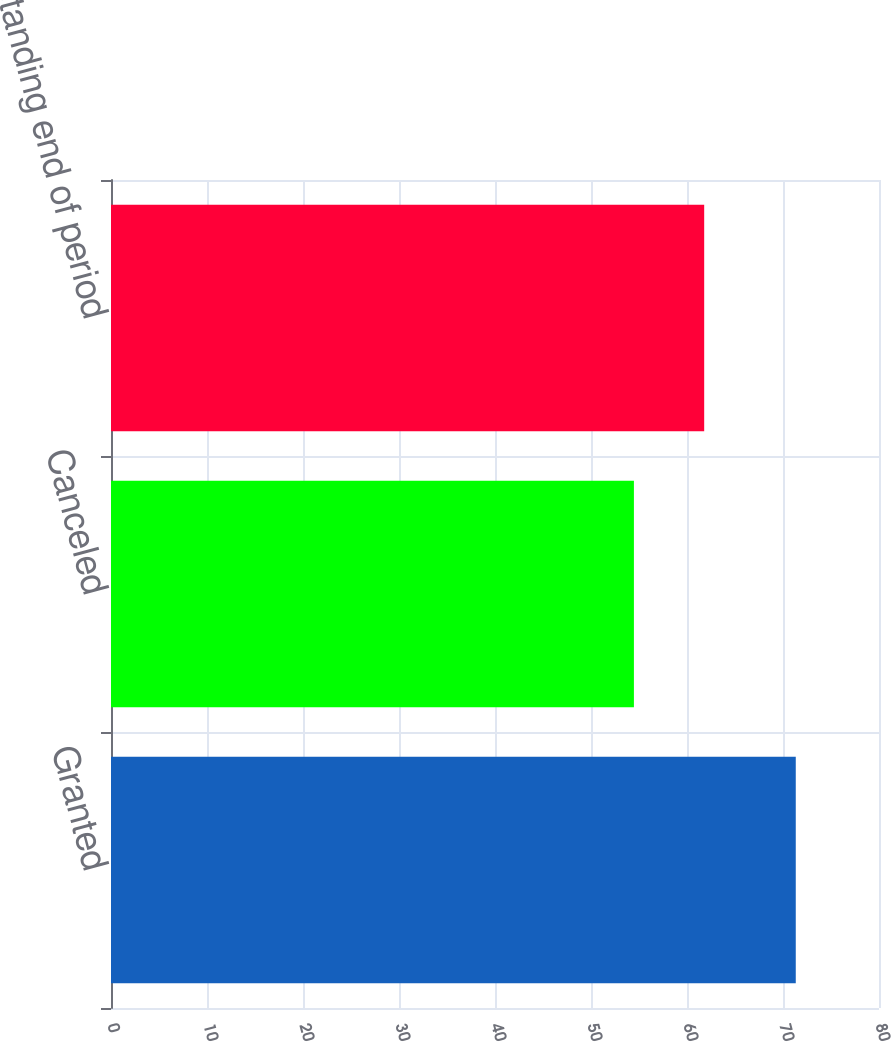Convert chart. <chart><loc_0><loc_0><loc_500><loc_500><bar_chart><fcel>Granted<fcel>Canceled<fcel>Outstanding end of period<nl><fcel>71.33<fcel>54.47<fcel>61.79<nl></chart> 